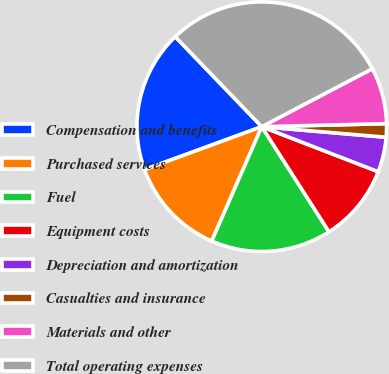Convert chart. <chart><loc_0><loc_0><loc_500><loc_500><pie_chart><fcel>Compensation and benefits<fcel>Purchased services<fcel>Fuel<fcel>Equipment costs<fcel>Depreciation and amortization<fcel>Casualties and insurance<fcel>Materials and other<fcel>Total operating expenses<nl><fcel>18.4%<fcel>12.85%<fcel>15.62%<fcel>10.07%<fcel>4.52%<fcel>1.74%<fcel>7.29%<fcel>29.5%<nl></chart> 